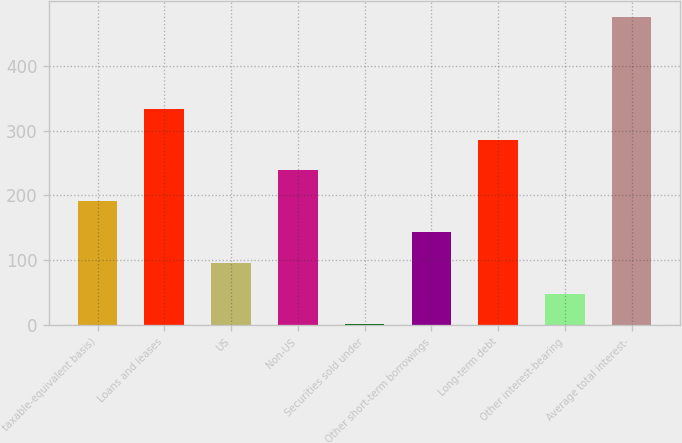Convert chart to OTSL. <chart><loc_0><loc_0><loc_500><loc_500><bar_chart><fcel>taxable-equivalent basis)<fcel>Loans and leases<fcel>US<fcel>Non-US<fcel>Securities sold under<fcel>Other short-term borrowings<fcel>Long-term debt<fcel>Other interest-bearing<fcel>Average total interest-<nl><fcel>191<fcel>333.5<fcel>96<fcel>238.5<fcel>1<fcel>143.5<fcel>286<fcel>48.5<fcel>476<nl></chart> 